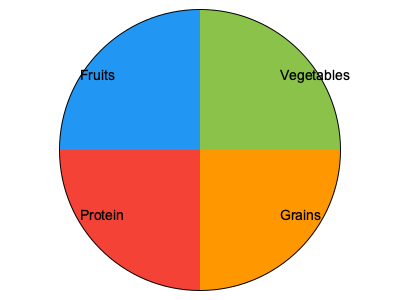Based on the visual plate model shown, which food group should occupy the largest portion of a child's meal, and approximately what percentage of the plate should it cover? To answer this question, we need to analyze the visual plate model provided:

1. The plate is divided into four sections, each representing a different food group.
2. The food groups shown are Vegetables, Grains, Protein, and Fruits.
3. By visually comparing the sizes of the sections, we can see that the Vegetables section is the largest.
4. To estimate the percentage, we need to consider that:
   a. The plate is a circle, which has 360 degrees.
   b. The Vegetables section appears to cover about 1/3 of the circle.
   c. 1/3 of 360 degrees is 120 degrees.
   d. 120 degrees / 360 degrees = 0.3333, or approximately 33.33%

5. Rounding to the nearest 5%, we can say that the Vegetables section covers about 35% of the plate.

Therefore, according to this visual plate model, vegetables should occupy the largest portion of a child's meal, covering approximately 35% of the plate.
Answer: Vegetables, 35% 